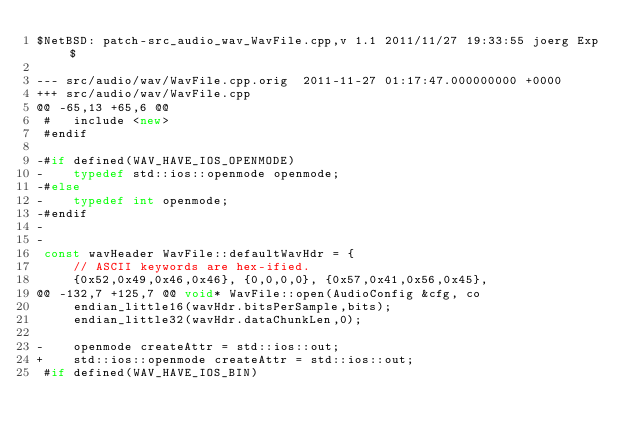Convert code to text. <code><loc_0><loc_0><loc_500><loc_500><_C++_>$NetBSD: patch-src_audio_wav_WavFile.cpp,v 1.1 2011/11/27 19:33:55 joerg Exp $

--- src/audio/wav/WavFile.cpp.orig	2011-11-27 01:17:47.000000000 +0000
+++ src/audio/wav/WavFile.cpp
@@ -65,13 +65,6 @@
 #   include <new>
 #endif
 
-#if defined(WAV_HAVE_IOS_OPENMODE)
-    typedef std::ios::openmode openmode;
-#else
-    typedef int openmode;
-#endif
-
-
 const wavHeader WavFile::defaultWavHdr = {
     // ASCII keywords are hex-ified.
     {0x52,0x49,0x46,0x46}, {0,0,0,0}, {0x57,0x41,0x56,0x45},
@@ -132,7 +125,7 @@ void* WavFile::open(AudioConfig &cfg, co
     endian_little16(wavHdr.bitsPerSample,bits);
     endian_little32(wavHdr.dataChunkLen,0);
 
-    openmode createAttr = std::ios::out;
+    std::ios::openmode createAttr = std::ios::out;
 #if defined(WAV_HAVE_IOS_BIN)</code> 